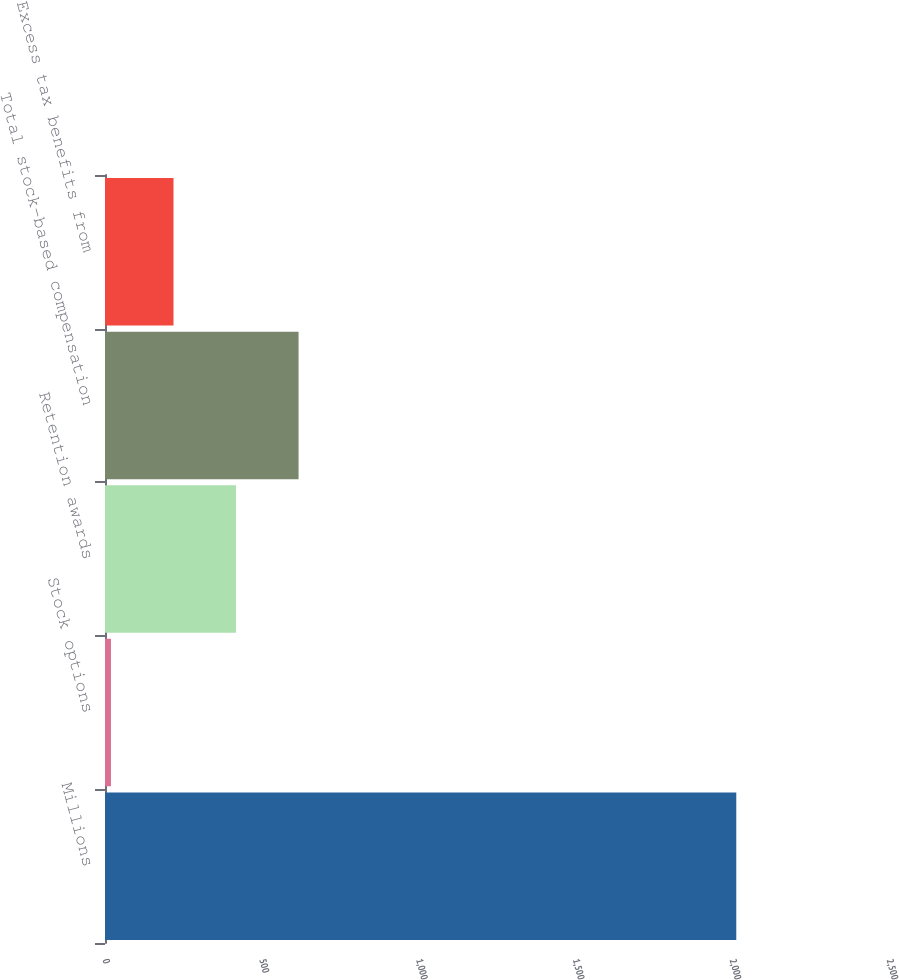<chart> <loc_0><loc_0><loc_500><loc_500><bar_chart><fcel>Millions<fcel>Stock options<fcel>Retention awards<fcel>Total stock-based compensation<fcel>Excess tax benefits from<nl><fcel>2013<fcel>19<fcel>417.8<fcel>617.2<fcel>218.4<nl></chart> 